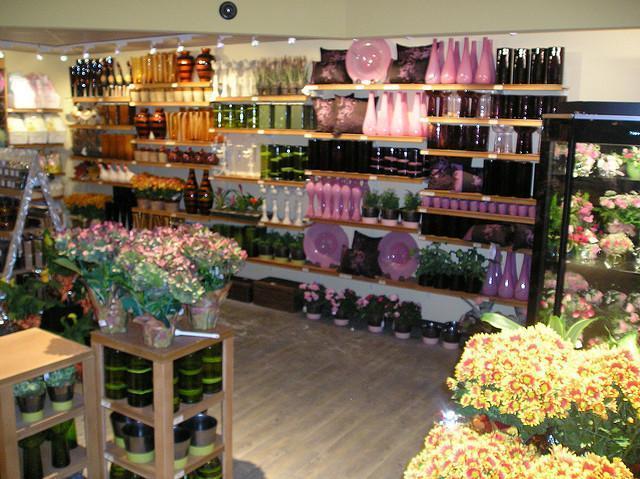How many vases are there?
Give a very brief answer. 1. How many potted plants are there?
Give a very brief answer. 4. 